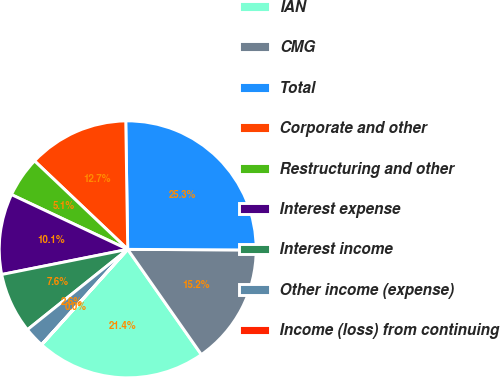<chart> <loc_0><loc_0><loc_500><loc_500><pie_chart><fcel>IAN<fcel>CMG<fcel>Total<fcel>Corporate and other<fcel>Restructuring and other<fcel>Interest expense<fcel>Interest income<fcel>Other income (expense)<fcel>Income (loss) from continuing<nl><fcel>21.4%<fcel>15.2%<fcel>25.32%<fcel>12.67%<fcel>5.08%<fcel>10.14%<fcel>7.61%<fcel>2.55%<fcel>0.02%<nl></chart> 